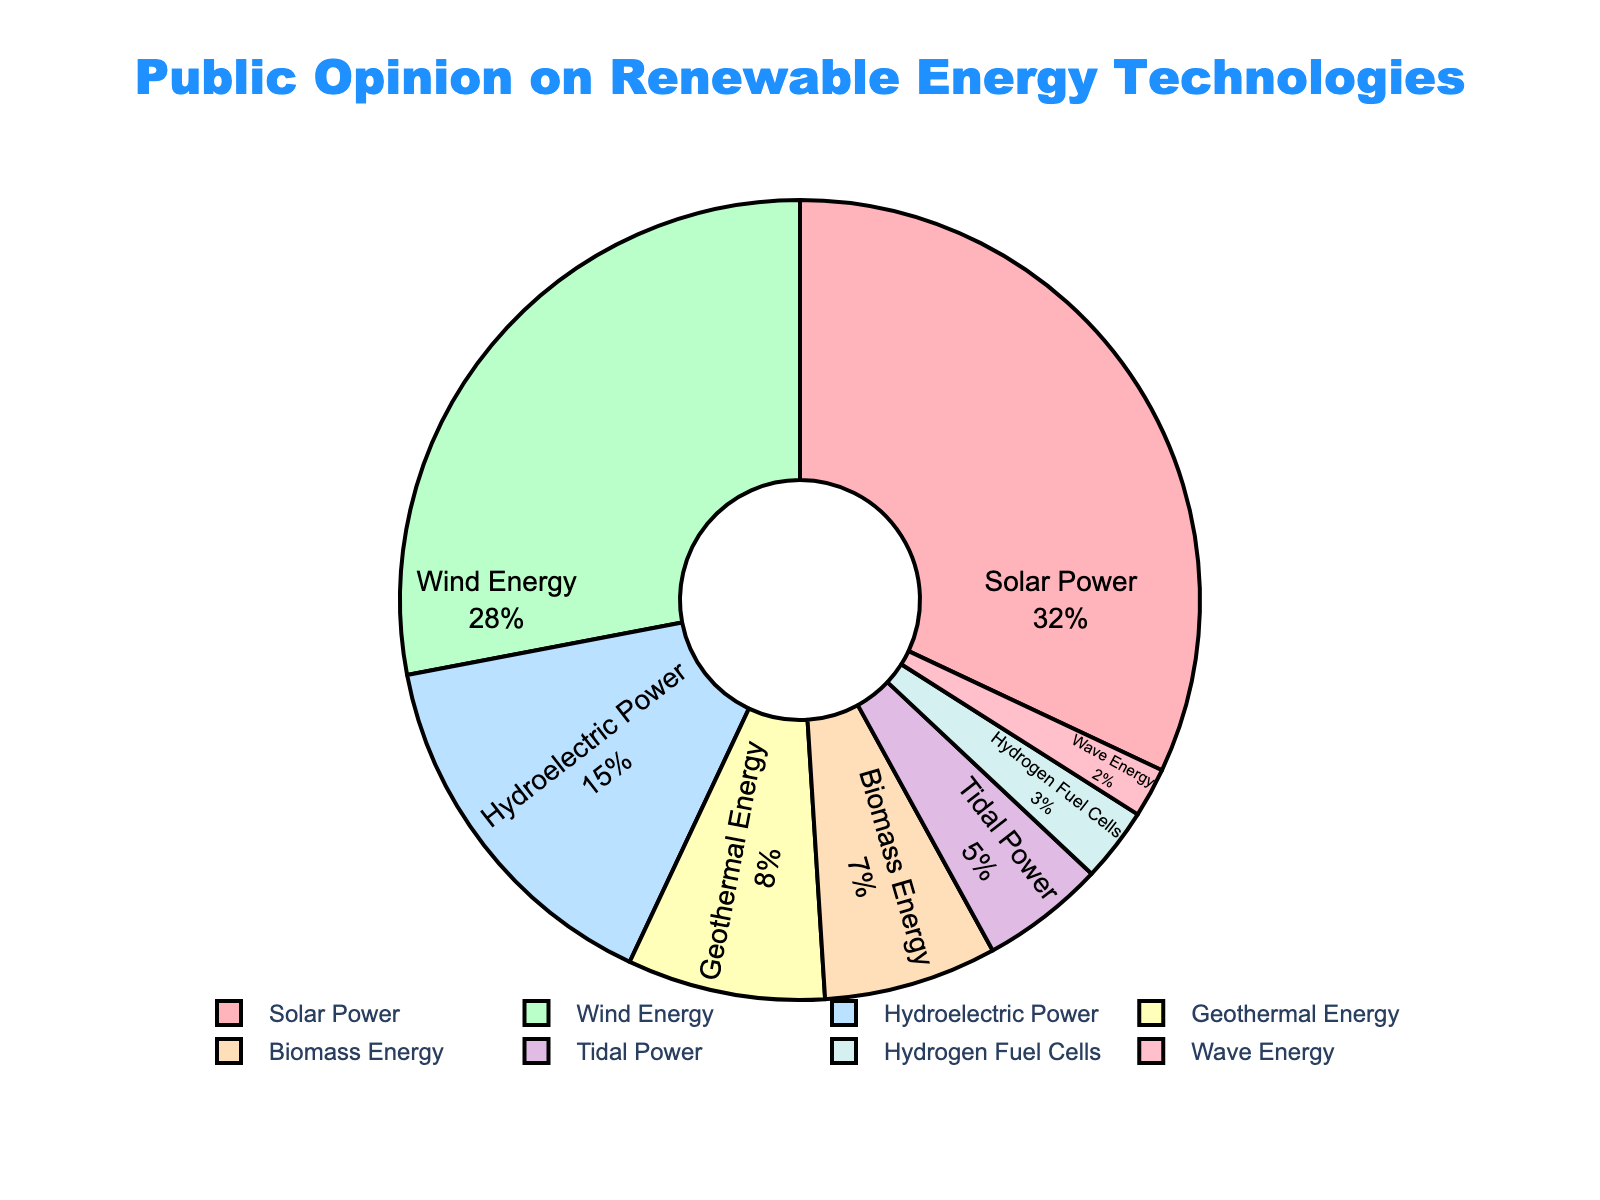what percentage of public opinion supports solar and wind energy combined? First, find the percentages for Solar Power and Wind Energy which are 32% and 28% respectively. Then sum these two values to get 32 + 28 = 60%
Answer: 60% how does the public opinion of geothermal energy compare to biomass energy? Compare the percentages of Geothermal Energy and Biomass Energy. Geothermal Energy has 8% and Biomass Energy has 7%, making Geothermal slightly higher.
Answer: Geothermal Energy has 1% higher opinion than Biomass Energy which technology has the lowest percentage of public support? Identify the technology with the smallest percentage in the dataset. Wave Energy has the lowest with 2%.
Answer: Wave Energy what is the combined percentage of the three least supported technologies? Identify the three lowest values: Wave Energy (2%), Hydrogen Fuel Cells (3%), and Tidal Power (5%). Sum these values: 2 + 3 + 5 = 10%
Answer: 10% Are Solar Power and Wind Energy collectively supported by more than 50% of the public? Sum the percentages of Solar Power and Wind Energy: 32 + 28 = 60%, which is greater than 50%.
Answer: Yes How much more popular is Solar Power compared to Hydrogen Fuel Cells? Subtract the percentage of Hydrogen Fuel Cells from that of Solar Power: 32 - 3 = 29%
Answer: 29% What is the average percentage of public support for Biomass Energy, Tidal Power, and Wave Energy? First add the percentages of Biomass Energy, Tidal Power, and Wave Energy: 7 + 5 + 2 = 14%. Then divide by the number of technologies: 14 / 3 ≈ 4.67%
Answer: 4.67% What proportion of the pie chart is taken up by Hydroelectric Power? The percentage for Hydroelectric Power is 15%. This means it takes up 15% of the pie chart.
Answer: 15% Is the percentage of support for Wind Energy greater than the combined support for Tidal Power and Wave Energy? First, find the combined percentage for Tidal Power and Wave Energy: 5 + 2 = 7%. Since Wind Energy has 28%, which is greater than 7%.
Answer: Yes 